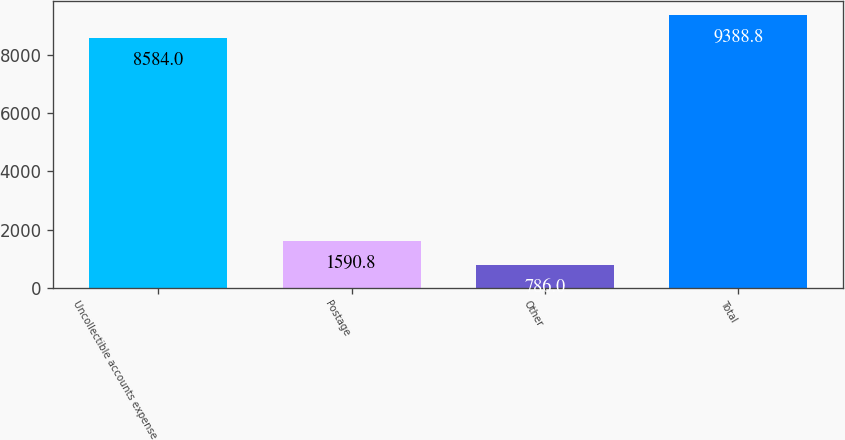Convert chart to OTSL. <chart><loc_0><loc_0><loc_500><loc_500><bar_chart><fcel>Uncollectible accounts expense<fcel>Postage<fcel>Other<fcel>Total<nl><fcel>8584<fcel>1590.8<fcel>786<fcel>9388.8<nl></chart> 